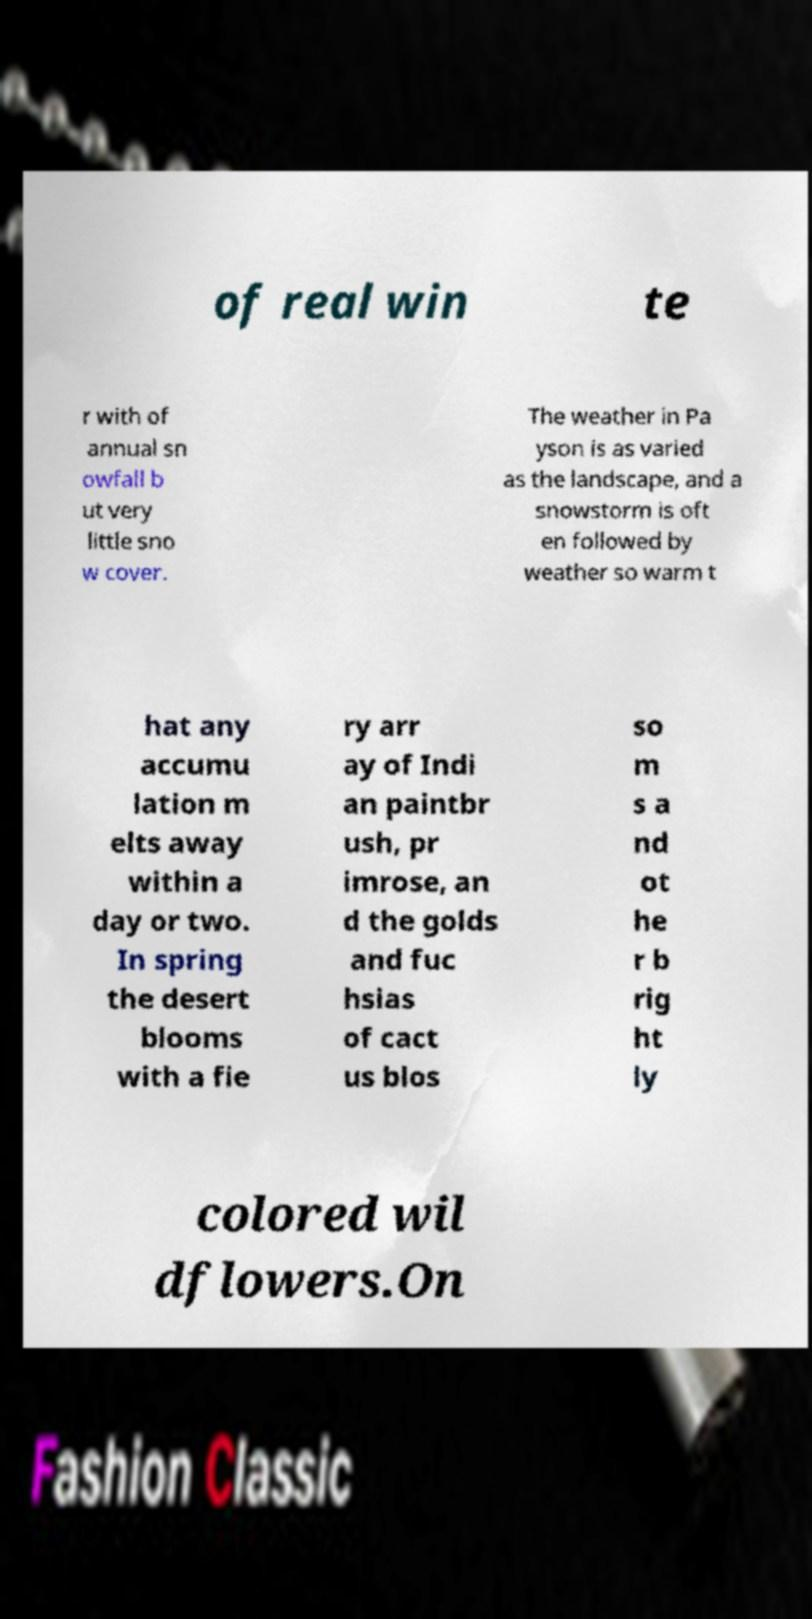What messages or text are displayed in this image? I need them in a readable, typed format. of real win te r with of annual sn owfall b ut very little sno w cover. The weather in Pa yson is as varied as the landscape, and a snowstorm is oft en followed by weather so warm t hat any accumu lation m elts away within a day or two. In spring the desert blooms with a fie ry arr ay of Indi an paintbr ush, pr imrose, an d the golds and fuc hsias of cact us blos so m s a nd ot he r b rig ht ly colored wil dflowers.On 